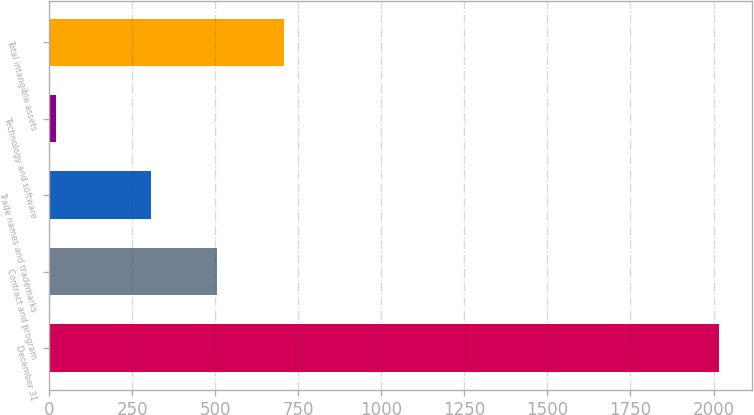Convert chart to OTSL. <chart><loc_0><loc_0><loc_500><loc_500><bar_chart><fcel>December 31<fcel>Contract and program<fcel>Trade names and trademarks<fcel>Technology and software<fcel>Total intangible assets<nl><fcel>2016<fcel>506.7<fcel>307<fcel>19<fcel>706.4<nl></chart> 